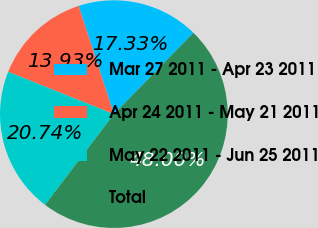Convert chart to OTSL. <chart><loc_0><loc_0><loc_500><loc_500><pie_chart><fcel>Mar 27 2011 - Apr 23 2011<fcel>Apr 24 2011 - May 21 2011<fcel>May 22 2011 - Jun 25 2011<fcel>Total<nl><fcel>17.33%<fcel>13.93%<fcel>20.74%<fcel>48.0%<nl></chart> 